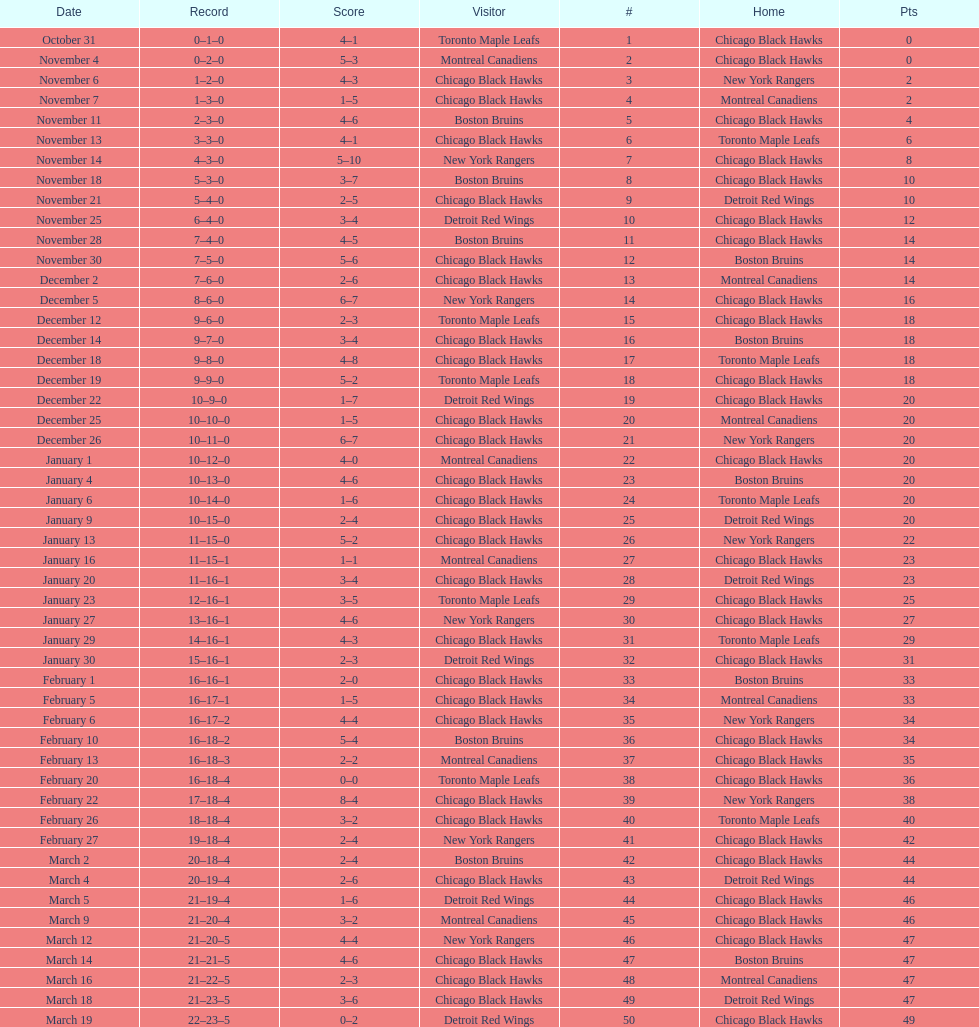How long is the duration of one season (from the first game to the last)? 5 months. 